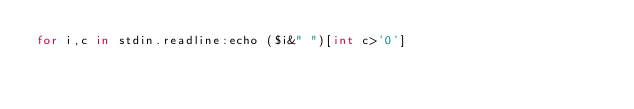<code> <loc_0><loc_0><loc_500><loc_500><_Nim_>for i,c in stdin.readline:echo ($i&" ")[int c>'0']</code> 